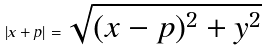<formula> <loc_0><loc_0><loc_500><loc_500>| x + p | = \sqrt { ( x - p ) ^ { 2 } + y ^ { 2 } }</formula> 